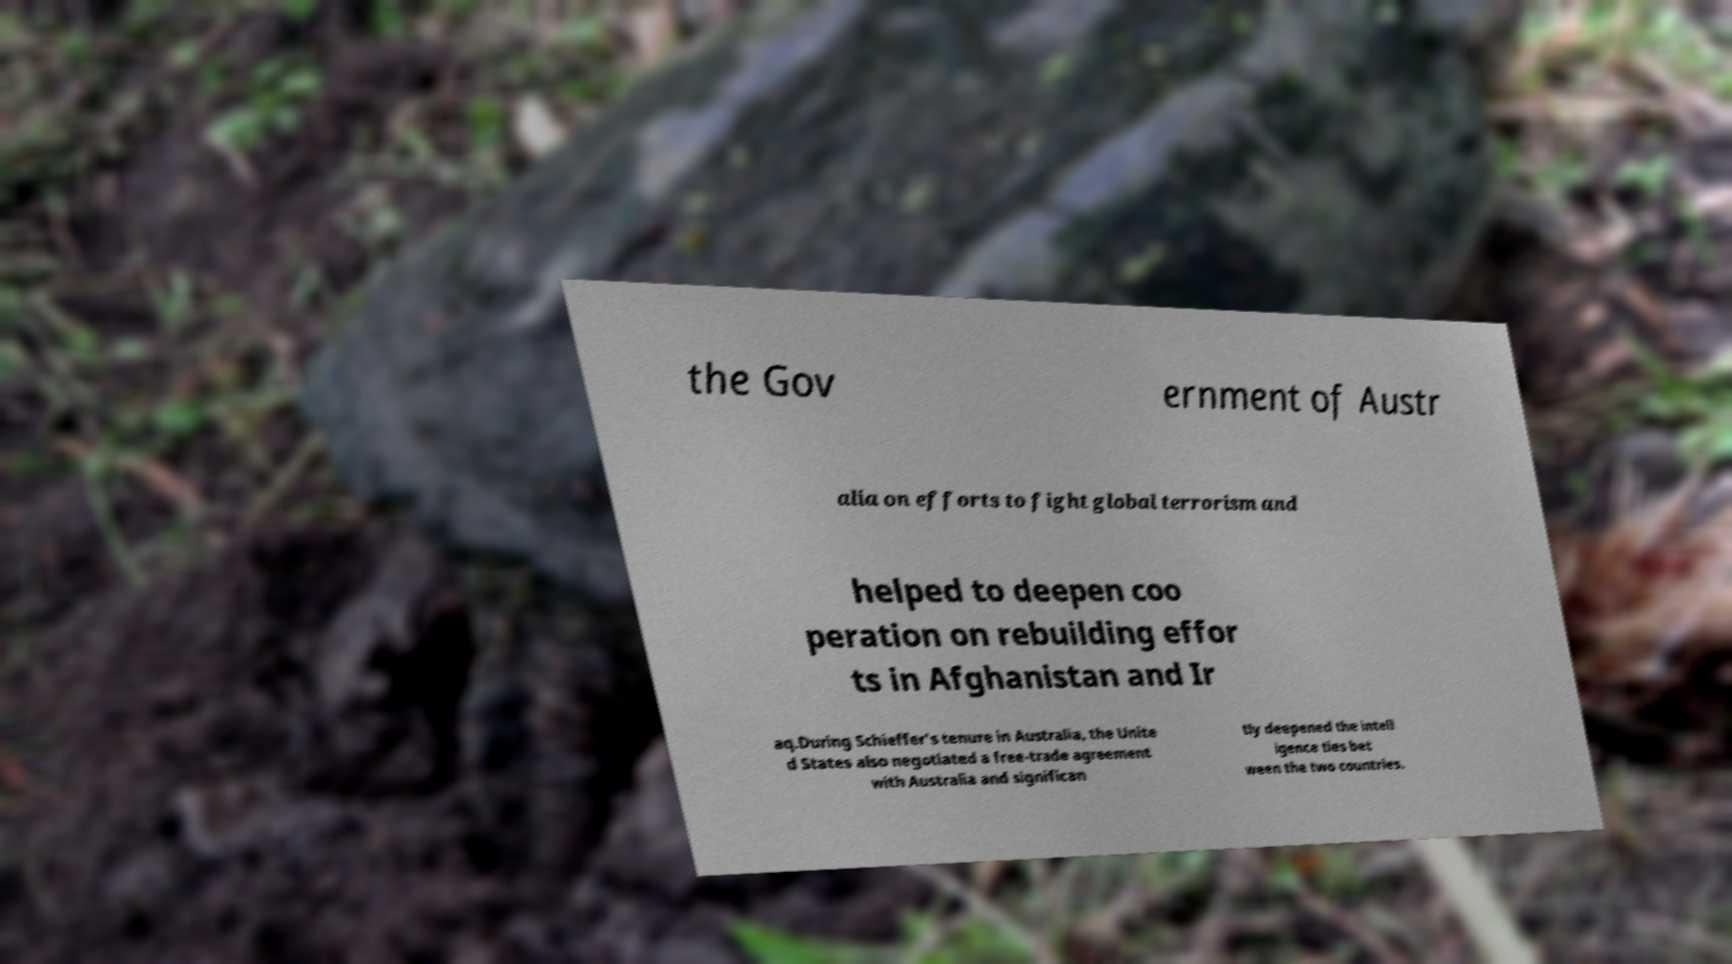For documentation purposes, I need the text within this image transcribed. Could you provide that? the Gov ernment of Austr alia on efforts to fight global terrorism and helped to deepen coo peration on rebuilding effor ts in Afghanistan and Ir aq.During Schieffer's tenure in Australia, the Unite d States also negotiated a free-trade agreement with Australia and significan tly deepened the intell igence ties bet ween the two countries. 